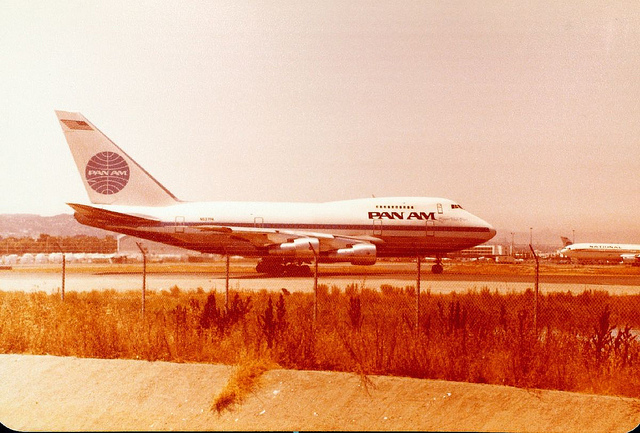Please identify all text content in this image. PANAM PANAM 